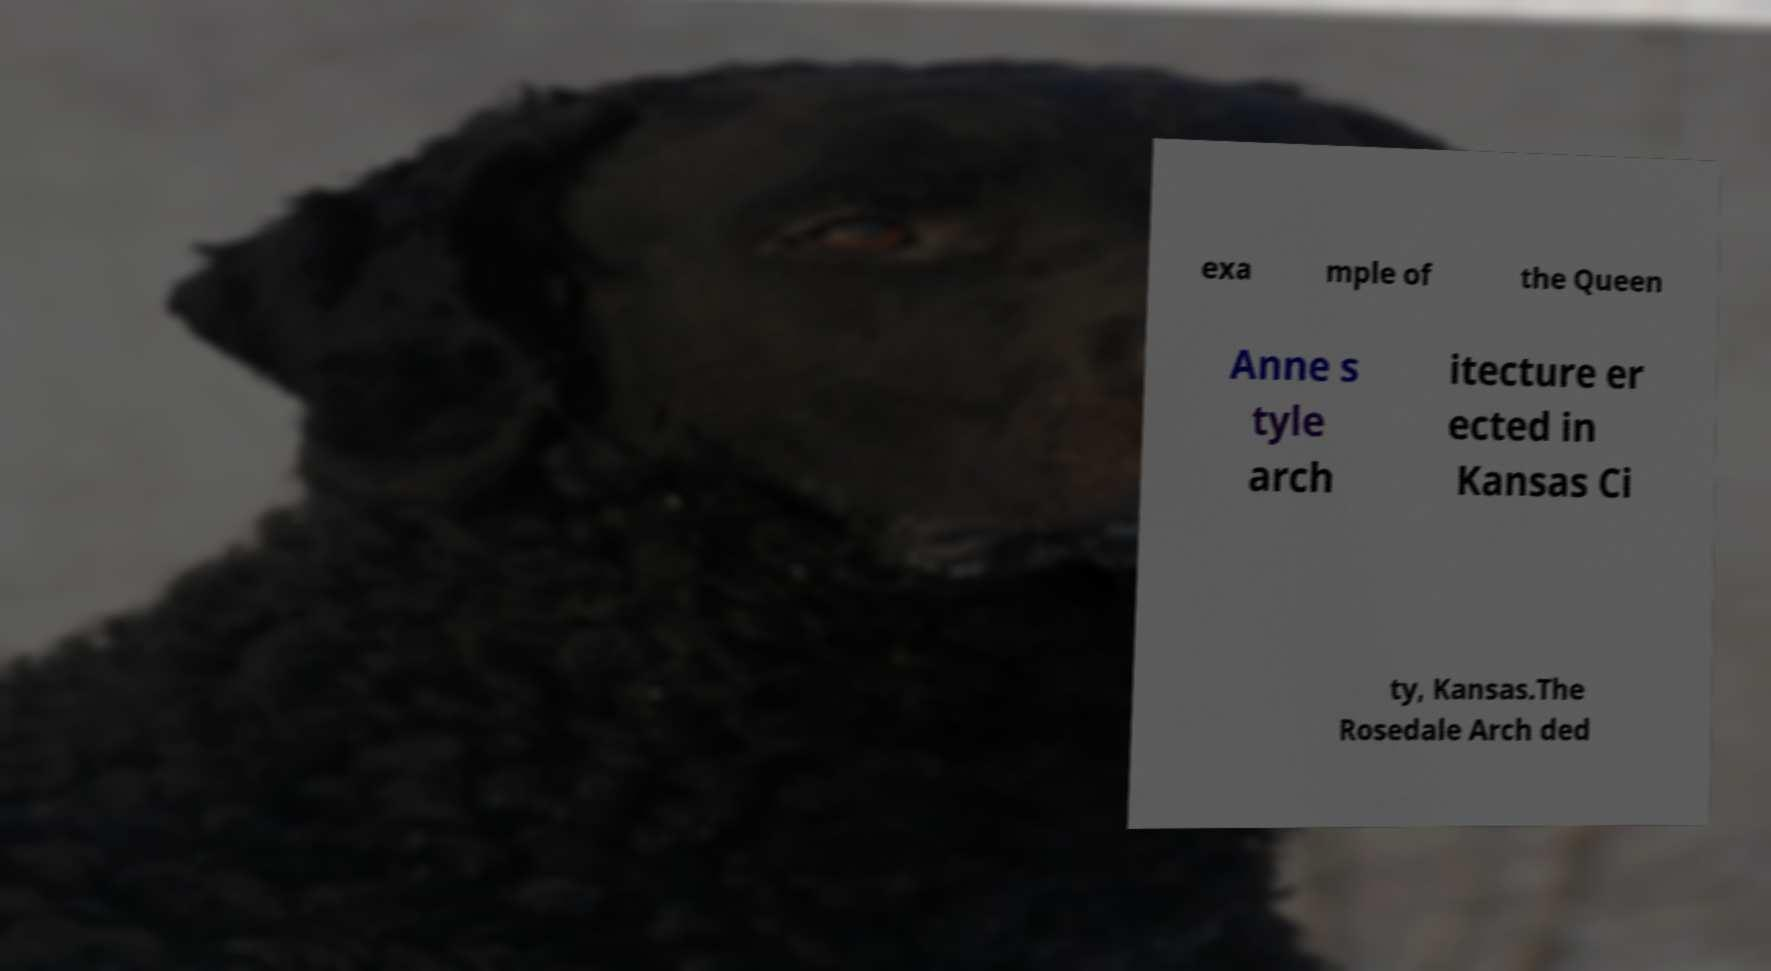There's text embedded in this image that I need extracted. Can you transcribe it verbatim? exa mple of the Queen Anne s tyle arch itecture er ected in Kansas Ci ty, Kansas.The Rosedale Arch ded 